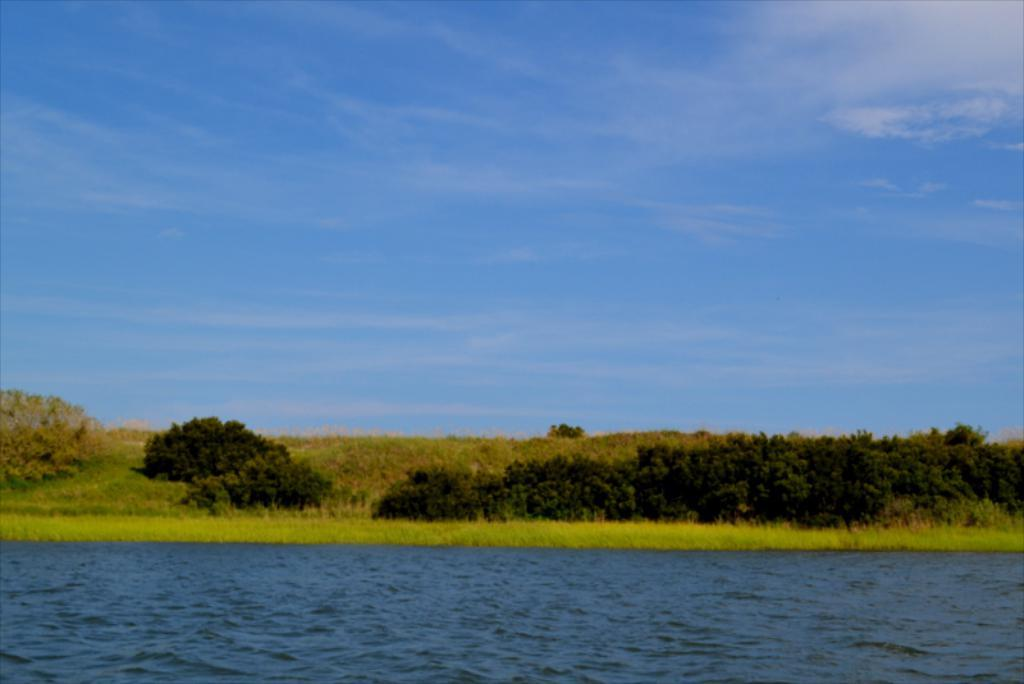What is one of the natural elements visible in the image? Water is visible in the image. What type of vegetation can be seen in the image? The image appears to depict grass. What other natural elements are present in the image? There are trees in the image. What is visible at the top of the image? The sky is visible at the top of the image. What can be observed in the sky? Clouds are present in the sky. What property is being adjusted in the image? There is no property being adjusted in the image; it is a static scene depicting natural elements. 